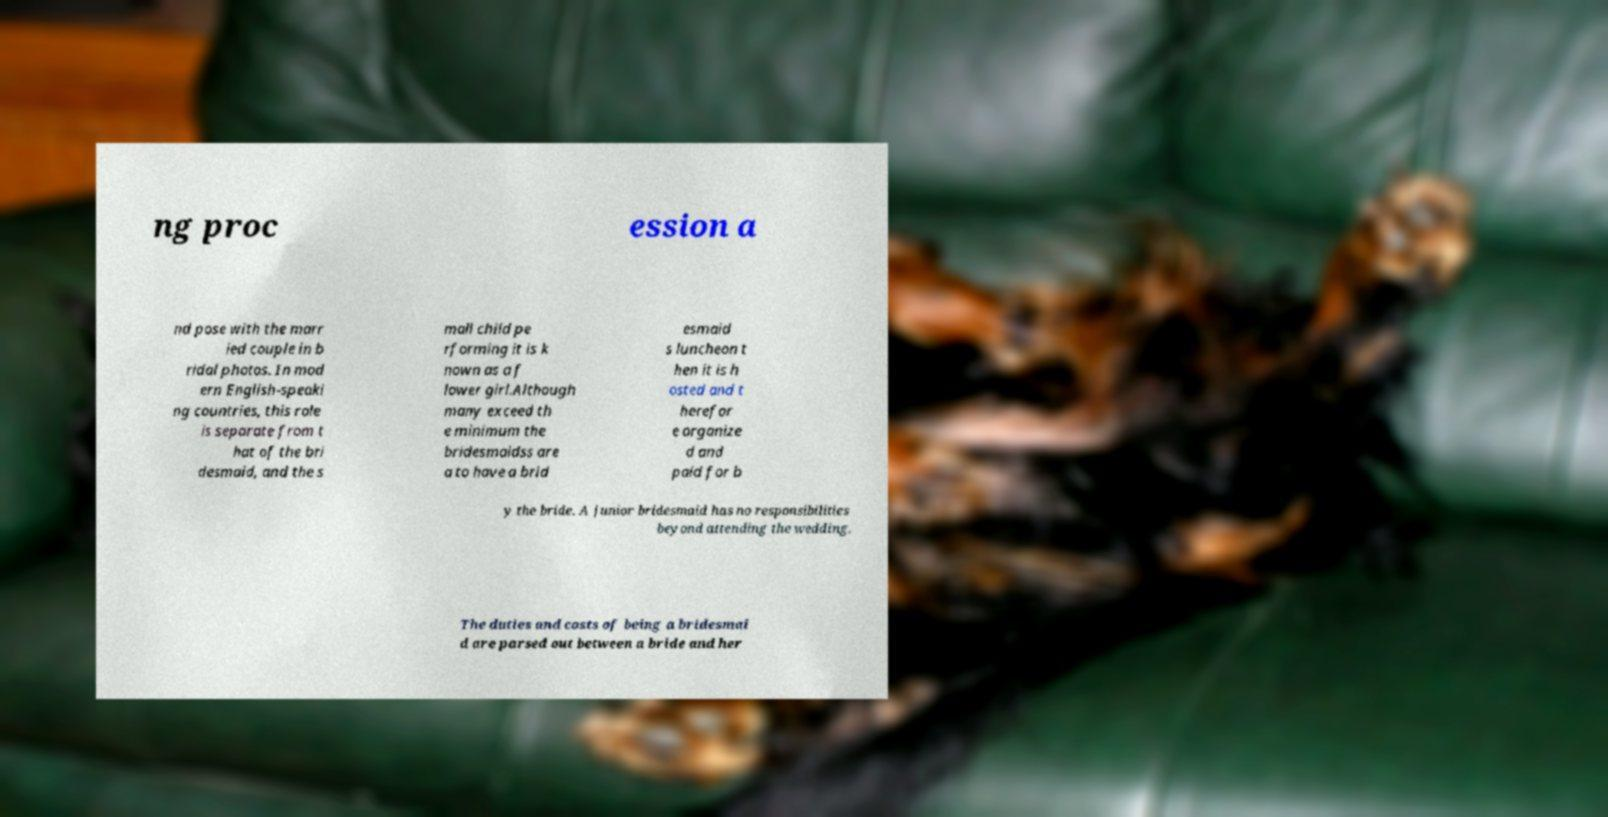Can you accurately transcribe the text from the provided image for me? ng proc ession a nd pose with the marr ied couple in b ridal photos. In mod ern English-speaki ng countries, this role is separate from t hat of the bri desmaid, and the s mall child pe rforming it is k nown as a f lower girl.Although many exceed th e minimum the bridesmaidss are a to have a brid esmaid s luncheon t hen it is h osted and t herefor e organize d and paid for b y the bride. A junior bridesmaid has no responsibilities beyond attending the wedding. The duties and costs of being a bridesmai d are parsed out between a bride and her 